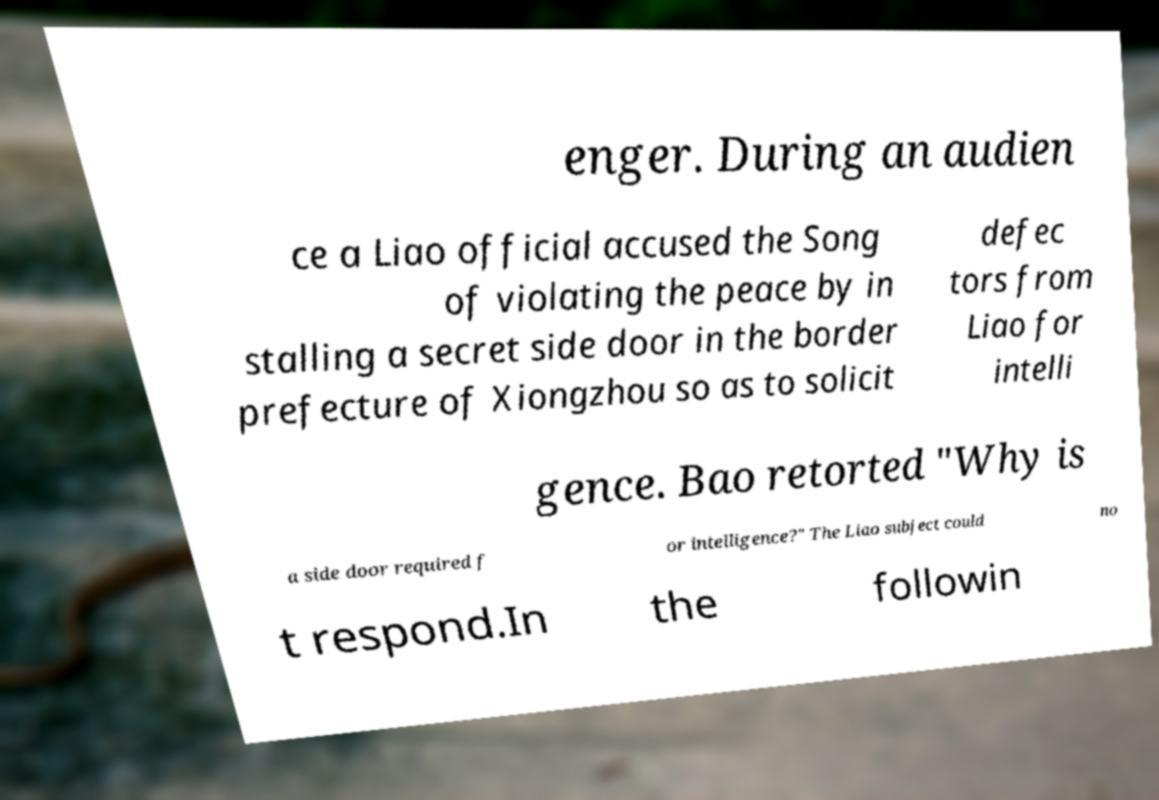There's text embedded in this image that I need extracted. Can you transcribe it verbatim? enger. During an audien ce a Liao official accused the Song of violating the peace by in stalling a secret side door in the border prefecture of Xiongzhou so as to solicit defec tors from Liao for intelli gence. Bao retorted "Why is a side door required f or intelligence?" The Liao subject could no t respond.In the followin 